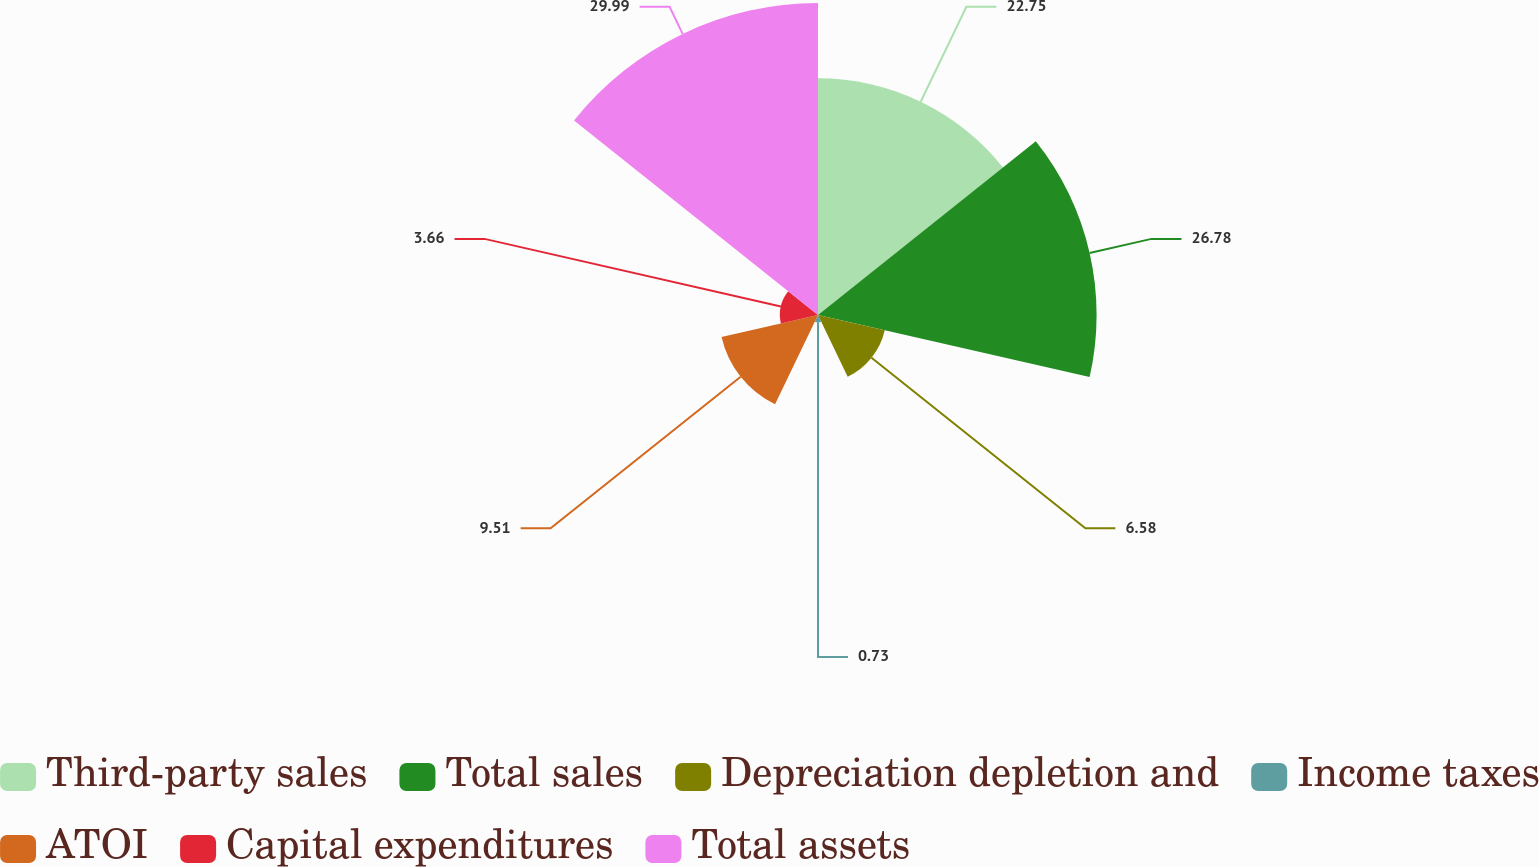Convert chart to OTSL. <chart><loc_0><loc_0><loc_500><loc_500><pie_chart><fcel>Third-party sales<fcel>Total sales<fcel>Depreciation depletion and<fcel>Income taxes<fcel>ATOI<fcel>Capital expenditures<fcel>Total assets<nl><fcel>22.75%<fcel>26.78%<fcel>6.58%<fcel>0.73%<fcel>9.51%<fcel>3.66%<fcel>29.99%<nl></chart> 